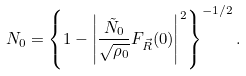Convert formula to latex. <formula><loc_0><loc_0><loc_500><loc_500>N _ { 0 } = \left \{ 1 - \left | { \frac { \tilde { N } _ { 0 } } { \sqrt { \rho _ { 0 } } } } F _ { \vec { R } } ( 0 ) \right | ^ { 2 } \right \} ^ { - 1 / 2 } .</formula> 